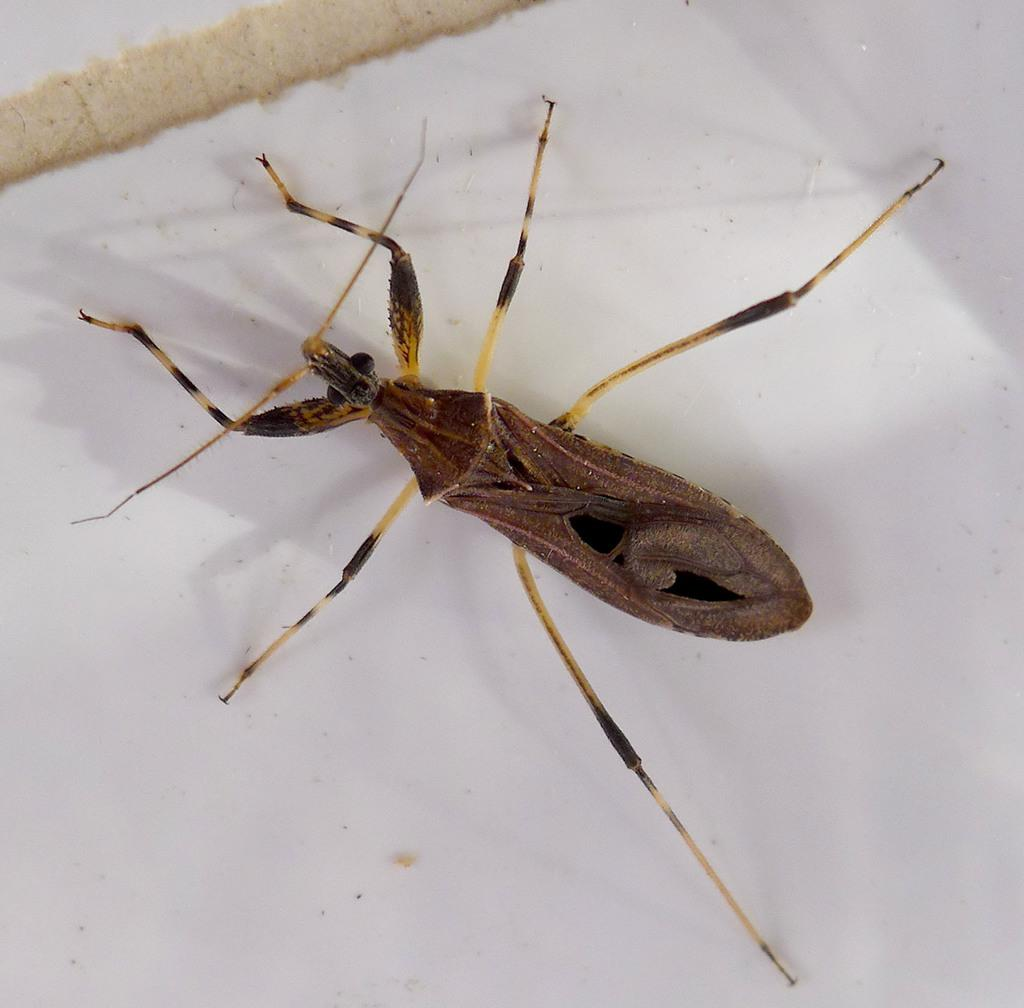What is the main subject of the image? There is a bug in the image. Where is the bug located in the image? The bug is in the front of the image. What can be seen in the background of the image? There is a wall in the background of the image. What type of insurance policy is being discussed in the image? There is no discussion of insurance policies in the image; it features a bug in the front and a wall in the background. 